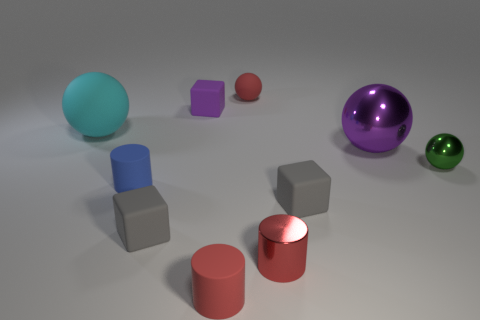Subtract 1 balls. How many balls are left? 3 Subtract all yellow spheres. Subtract all red cylinders. How many spheres are left? 4 Subtract all cylinders. How many objects are left? 7 Add 1 small rubber cylinders. How many small rubber cylinders exist? 3 Subtract 0 brown balls. How many objects are left? 10 Subtract all tiny rubber blocks. Subtract all small red metallic objects. How many objects are left? 6 Add 8 metallic spheres. How many metallic spheres are left? 10 